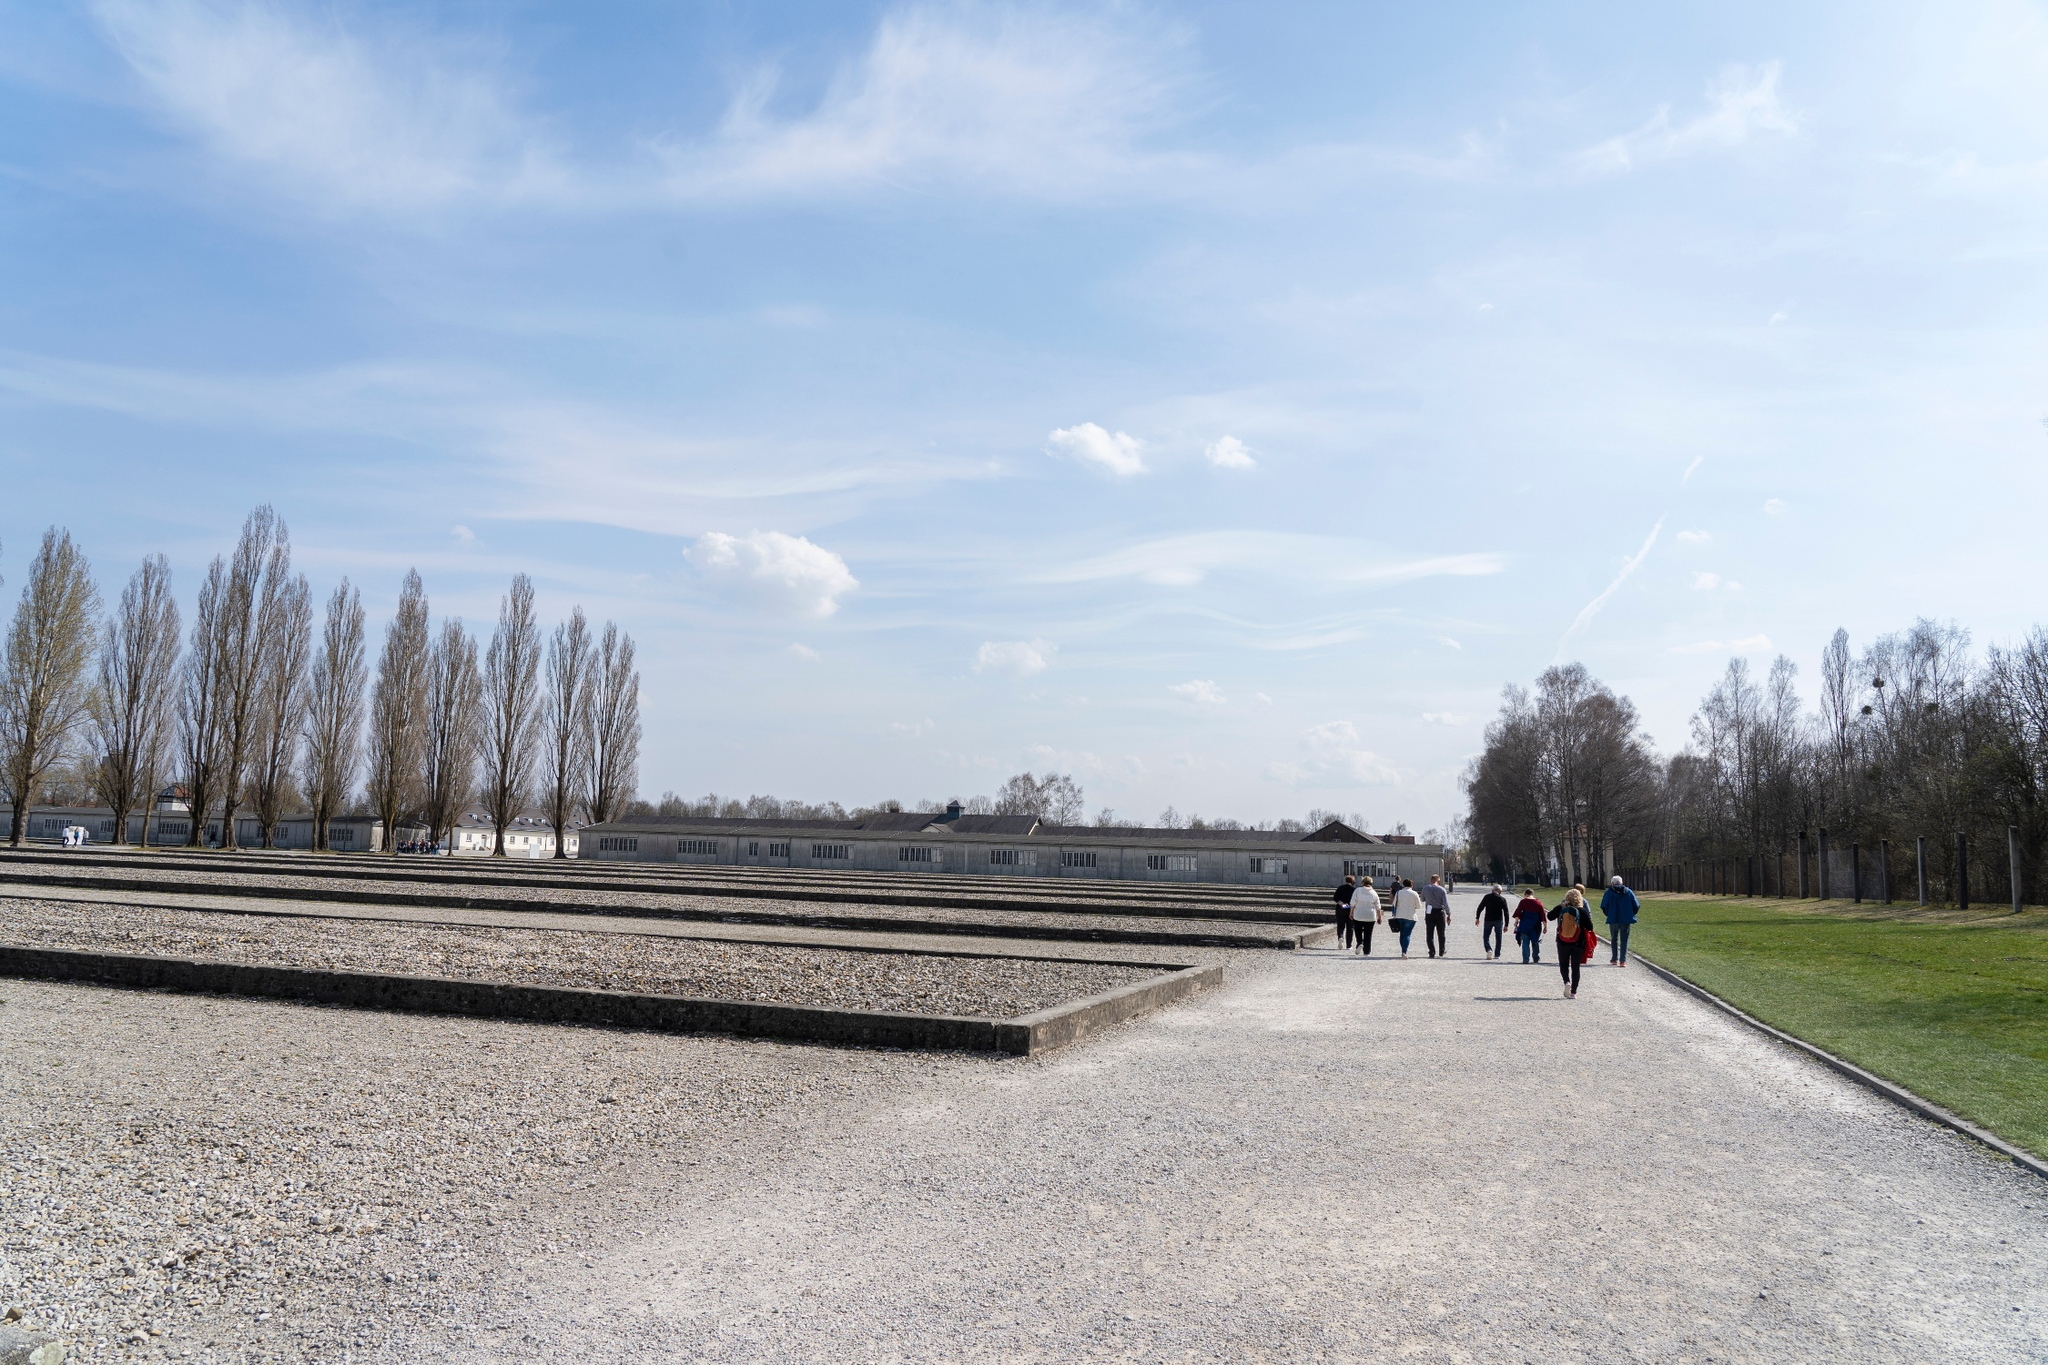If you could imagine a conversation between the visitors in the image, what would they be discussing? Given the historical significance of the Dachau Concentration Camp Memorial Site, it is likely that the visitors are discussing the historical events that took place here, reflecting on the experience and emotions it evokes. They might be talking about the lives lost during the Holocaust, the importance of remembering such events, and the lessons that history imparts to modern society. The conversation could also include thoughts on how the memorial has been preserved and the impact it has on contemporary culture and education. 